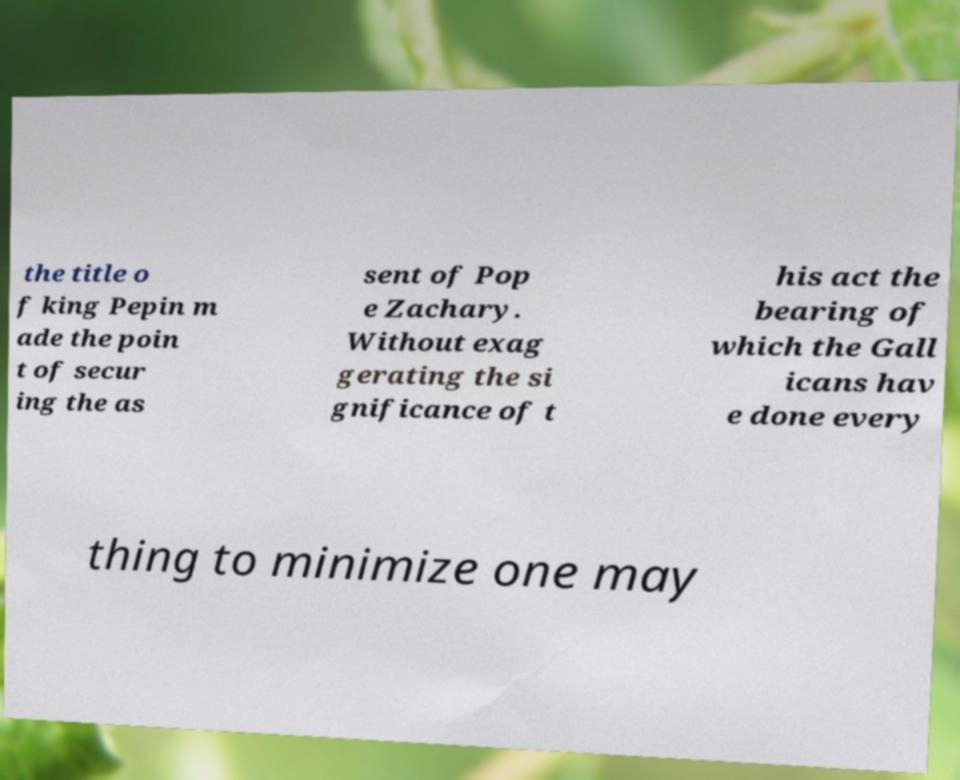Can you accurately transcribe the text from the provided image for me? the title o f king Pepin m ade the poin t of secur ing the as sent of Pop e Zachary. Without exag gerating the si gnificance of t his act the bearing of which the Gall icans hav e done every thing to minimize one may 